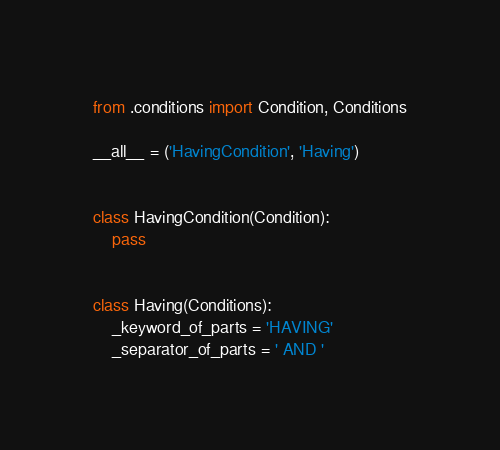Convert code to text. <code><loc_0><loc_0><loc_500><loc_500><_Python_>from .conditions import Condition, Conditions

__all__ = ('HavingCondition', 'Having')


class HavingCondition(Condition):
    pass


class Having(Conditions):
    _keyword_of_parts = 'HAVING'
    _separator_of_parts = ' AND '
</code> 